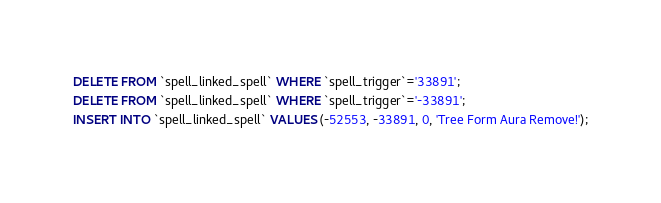<code> <loc_0><loc_0><loc_500><loc_500><_SQL_>DELETE FROM `spell_linked_spell` WHERE `spell_trigger`='33891';
DELETE FROM `spell_linked_spell` WHERE `spell_trigger`='-33891';
INSERT INTO `spell_linked_spell` VALUES (-52553, -33891, 0, 'Tree Form Aura Remove!');</code> 